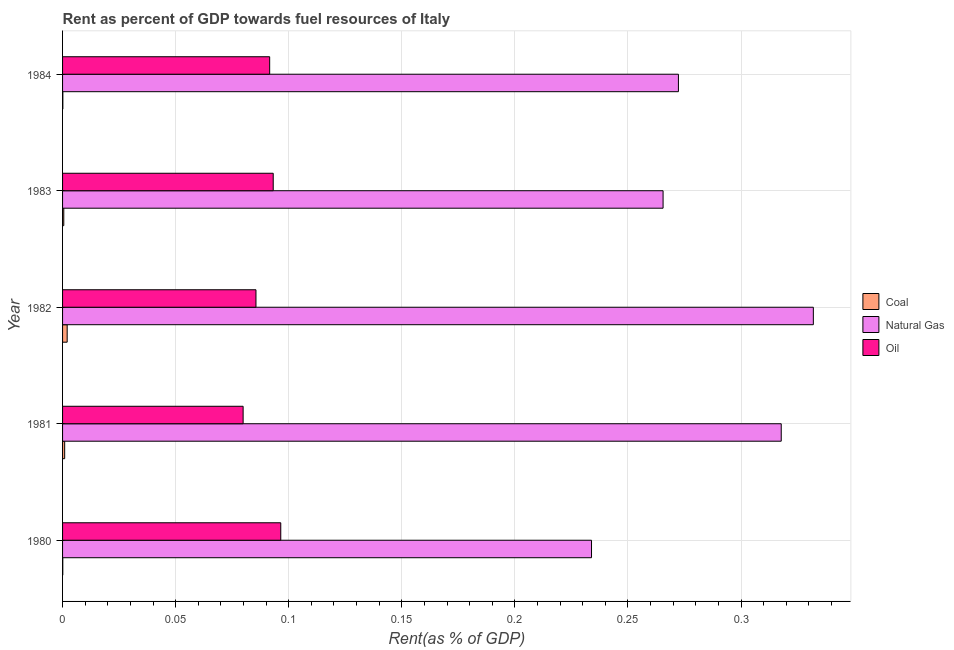How many different coloured bars are there?
Your answer should be compact. 3. Are the number of bars per tick equal to the number of legend labels?
Your answer should be very brief. Yes. Are the number of bars on each tick of the Y-axis equal?
Your response must be concise. Yes. How many bars are there on the 2nd tick from the bottom?
Offer a very short reply. 3. What is the label of the 2nd group of bars from the top?
Offer a very short reply. 1983. What is the rent towards coal in 1984?
Keep it short and to the point. 0. Across all years, what is the maximum rent towards oil?
Your answer should be very brief. 0.1. Across all years, what is the minimum rent towards oil?
Offer a very short reply. 0.08. What is the total rent towards oil in the graph?
Your answer should be compact. 0.45. What is the difference between the rent towards coal in 1980 and that in 1984?
Make the answer very short. -0. What is the difference between the rent towards coal in 1983 and the rent towards oil in 1981?
Offer a terse response. -0.08. What is the average rent towards coal per year?
Make the answer very short. 0. In the year 1984, what is the difference between the rent towards oil and rent towards natural gas?
Keep it short and to the point. -0.18. In how many years, is the rent towards coal greater than 0.03 %?
Your answer should be very brief. 0. What is the ratio of the rent towards oil in 1980 to that in 1981?
Keep it short and to the point. 1.21. Is the difference between the rent towards coal in 1981 and 1982 greater than the difference between the rent towards natural gas in 1981 and 1982?
Give a very brief answer. Yes. What is the difference between the highest and the second highest rent towards natural gas?
Give a very brief answer. 0.01. What does the 3rd bar from the top in 1980 represents?
Give a very brief answer. Coal. What does the 2nd bar from the bottom in 1983 represents?
Your answer should be compact. Natural Gas. Is it the case that in every year, the sum of the rent towards coal and rent towards natural gas is greater than the rent towards oil?
Make the answer very short. Yes. How many bars are there?
Provide a short and direct response. 15. Are all the bars in the graph horizontal?
Ensure brevity in your answer.  Yes. Are the values on the major ticks of X-axis written in scientific E-notation?
Your answer should be very brief. No. Where does the legend appear in the graph?
Your response must be concise. Center right. How many legend labels are there?
Your answer should be very brief. 3. What is the title of the graph?
Your answer should be very brief. Rent as percent of GDP towards fuel resources of Italy. Does "Ages 20-60" appear as one of the legend labels in the graph?
Make the answer very short. No. What is the label or title of the X-axis?
Offer a terse response. Rent(as % of GDP). What is the label or title of the Y-axis?
Provide a succinct answer. Year. What is the Rent(as % of GDP) in Coal in 1980?
Your answer should be compact. 9.6418290567852e-5. What is the Rent(as % of GDP) in Natural Gas in 1980?
Your response must be concise. 0.23. What is the Rent(as % of GDP) of Oil in 1980?
Your answer should be very brief. 0.1. What is the Rent(as % of GDP) of Coal in 1981?
Provide a short and direct response. 0. What is the Rent(as % of GDP) in Natural Gas in 1981?
Give a very brief answer. 0.32. What is the Rent(as % of GDP) of Oil in 1981?
Provide a short and direct response. 0.08. What is the Rent(as % of GDP) in Coal in 1982?
Your response must be concise. 0. What is the Rent(as % of GDP) in Natural Gas in 1982?
Offer a terse response. 0.33. What is the Rent(as % of GDP) of Oil in 1982?
Offer a terse response. 0.09. What is the Rent(as % of GDP) of Coal in 1983?
Provide a short and direct response. 0. What is the Rent(as % of GDP) of Natural Gas in 1983?
Provide a succinct answer. 0.27. What is the Rent(as % of GDP) of Oil in 1983?
Give a very brief answer. 0.09. What is the Rent(as % of GDP) in Coal in 1984?
Offer a terse response. 0. What is the Rent(as % of GDP) in Natural Gas in 1984?
Give a very brief answer. 0.27. What is the Rent(as % of GDP) of Oil in 1984?
Give a very brief answer. 0.09. Across all years, what is the maximum Rent(as % of GDP) in Coal?
Your answer should be compact. 0. Across all years, what is the maximum Rent(as % of GDP) of Natural Gas?
Ensure brevity in your answer.  0.33. Across all years, what is the maximum Rent(as % of GDP) in Oil?
Keep it short and to the point. 0.1. Across all years, what is the minimum Rent(as % of GDP) in Coal?
Your answer should be compact. 9.6418290567852e-5. Across all years, what is the minimum Rent(as % of GDP) of Natural Gas?
Offer a very short reply. 0.23. Across all years, what is the minimum Rent(as % of GDP) of Oil?
Ensure brevity in your answer.  0.08. What is the total Rent(as % of GDP) of Coal in the graph?
Offer a terse response. 0. What is the total Rent(as % of GDP) in Natural Gas in the graph?
Ensure brevity in your answer.  1.42. What is the total Rent(as % of GDP) in Oil in the graph?
Provide a succinct answer. 0.45. What is the difference between the Rent(as % of GDP) of Coal in 1980 and that in 1981?
Give a very brief answer. -0. What is the difference between the Rent(as % of GDP) of Natural Gas in 1980 and that in 1981?
Offer a terse response. -0.08. What is the difference between the Rent(as % of GDP) of Oil in 1980 and that in 1981?
Make the answer very short. 0.02. What is the difference between the Rent(as % of GDP) in Coal in 1980 and that in 1982?
Ensure brevity in your answer.  -0. What is the difference between the Rent(as % of GDP) in Natural Gas in 1980 and that in 1982?
Offer a very short reply. -0.1. What is the difference between the Rent(as % of GDP) of Oil in 1980 and that in 1982?
Your answer should be very brief. 0.01. What is the difference between the Rent(as % of GDP) of Coal in 1980 and that in 1983?
Your answer should be compact. -0. What is the difference between the Rent(as % of GDP) in Natural Gas in 1980 and that in 1983?
Provide a short and direct response. -0.03. What is the difference between the Rent(as % of GDP) of Oil in 1980 and that in 1983?
Provide a short and direct response. 0. What is the difference between the Rent(as % of GDP) in Coal in 1980 and that in 1984?
Offer a terse response. -0. What is the difference between the Rent(as % of GDP) in Natural Gas in 1980 and that in 1984?
Provide a short and direct response. -0.04. What is the difference between the Rent(as % of GDP) in Oil in 1980 and that in 1984?
Give a very brief answer. 0. What is the difference between the Rent(as % of GDP) in Coal in 1981 and that in 1982?
Make the answer very short. -0. What is the difference between the Rent(as % of GDP) in Natural Gas in 1981 and that in 1982?
Your answer should be very brief. -0.01. What is the difference between the Rent(as % of GDP) in Oil in 1981 and that in 1982?
Ensure brevity in your answer.  -0.01. What is the difference between the Rent(as % of GDP) in Natural Gas in 1981 and that in 1983?
Your response must be concise. 0.05. What is the difference between the Rent(as % of GDP) of Oil in 1981 and that in 1983?
Make the answer very short. -0.01. What is the difference between the Rent(as % of GDP) of Coal in 1981 and that in 1984?
Offer a very short reply. 0. What is the difference between the Rent(as % of GDP) in Natural Gas in 1981 and that in 1984?
Ensure brevity in your answer.  0.05. What is the difference between the Rent(as % of GDP) in Oil in 1981 and that in 1984?
Offer a terse response. -0.01. What is the difference between the Rent(as % of GDP) of Coal in 1982 and that in 1983?
Give a very brief answer. 0. What is the difference between the Rent(as % of GDP) in Natural Gas in 1982 and that in 1983?
Keep it short and to the point. 0.07. What is the difference between the Rent(as % of GDP) in Oil in 1982 and that in 1983?
Offer a very short reply. -0.01. What is the difference between the Rent(as % of GDP) in Coal in 1982 and that in 1984?
Offer a very short reply. 0. What is the difference between the Rent(as % of GDP) in Natural Gas in 1982 and that in 1984?
Make the answer very short. 0.06. What is the difference between the Rent(as % of GDP) in Oil in 1982 and that in 1984?
Your answer should be compact. -0.01. What is the difference between the Rent(as % of GDP) in Natural Gas in 1983 and that in 1984?
Provide a short and direct response. -0.01. What is the difference between the Rent(as % of GDP) in Oil in 1983 and that in 1984?
Keep it short and to the point. 0. What is the difference between the Rent(as % of GDP) in Coal in 1980 and the Rent(as % of GDP) in Natural Gas in 1981?
Provide a short and direct response. -0.32. What is the difference between the Rent(as % of GDP) in Coal in 1980 and the Rent(as % of GDP) in Oil in 1981?
Give a very brief answer. -0.08. What is the difference between the Rent(as % of GDP) of Natural Gas in 1980 and the Rent(as % of GDP) of Oil in 1981?
Your answer should be compact. 0.15. What is the difference between the Rent(as % of GDP) of Coal in 1980 and the Rent(as % of GDP) of Natural Gas in 1982?
Give a very brief answer. -0.33. What is the difference between the Rent(as % of GDP) in Coal in 1980 and the Rent(as % of GDP) in Oil in 1982?
Offer a very short reply. -0.09. What is the difference between the Rent(as % of GDP) in Natural Gas in 1980 and the Rent(as % of GDP) in Oil in 1982?
Ensure brevity in your answer.  0.15. What is the difference between the Rent(as % of GDP) in Coal in 1980 and the Rent(as % of GDP) in Natural Gas in 1983?
Provide a succinct answer. -0.27. What is the difference between the Rent(as % of GDP) of Coal in 1980 and the Rent(as % of GDP) of Oil in 1983?
Your answer should be compact. -0.09. What is the difference between the Rent(as % of GDP) in Natural Gas in 1980 and the Rent(as % of GDP) in Oil in 1983?
Offer a terse response. 0.14. What is the difference between the Rent(as % of GDP) of Coal in 1980 and the Rent(as % of GDP) of Natural Gas in 1984?
Make the answer very short. -0.27. What is the difference between the Rent(as % of GDP) in Coal in 1980 and the Rent(as % of GDP) in Oil in 1984?
Give a very brief answer. -0.09. What is the difference between the Rent(as % of GDP) of Natural Gas in 1980 and the Rent(as % of GDP) of Oil in 1984?
Offer a very short reply. 0.14. What is the difference between the Rent(as % of GDP) of Coal in 1981 and the Rent(as % of GDP) of Natural Gas in 1982?
Make the answer very short. -0.33. What is the difference between the Rent(as % of GDP) of Coal in 1981 and the Rent(as % of GDP) of Oil in 1982?
Your response must be concise. -0.08. What is the difference between the Rent(as % of GDP) in Natural Gas in 1981 and the Rent(as % of GDP) in Oil in 1982?
Ensure brevity in your answer.  0.23. What is the difference between the Rent(as % of GDP) of Coal in 1981 and the Rent(as % of GDP) of Natural Gas in 1983?
Provide a short and direct response. -0.26. What is the difference between the Rent(as % of GDP) in Coal in 1981 and the Rent(as % of GDP) in Oil in 1983?
Your answer should be compact. -0.09. What is the difference between the Rent(as % of GDP) of Natural Gas in 1981 and the Rent(as % of GDP) of Oil in 1983?
Keep it short and to the point. 0.22. What is the difference between the Rent(as % of GDP) of Coal in 1981 and the Rent(as % of GDP) of Natural Gas in 1984?
Give a very brief answer. -0.27. What is the difference between the Rent(as % of GDP) in Coal in 1981 and the Rent(as % of GDP) in Oil in 1984?
Provide a succinct answer. -0.09. What is the difference between the Rent(as % of GDP) in Natural Gas in 1981 and the Rent(as % of GDP) in Oil in 1984?
Your answer should be compact. 0.23. What is the difference between the Rent(as % of GDP) of Coal in 1982 and the Rent(as % of GDP) of Natural Gas in 1983?
Offer a very short reply. -0.26. What is the difference between the Rent(as % of GDP) in Coal in 1982 and the Rent(as % of GDP) in Oil in 1983?
Ensure brevity in your answer.  -0.09. What is the difference between the Rent(as % of GDP) in Natural Gas in 1982 and the Rent(as % of GDP) in Oil in 1983?
Your response must be concise. 0.24. What is the difference between the Rent(as % of GDP) in Coal in 1982 and the Rent(as % of GDP) in Natural Gas in 1984?
Give a very brief answer. -0.27. What is the difference between the Rent(as % of GDP) of Coal in 1982 and the Rent(as % of GDP) of Oil in 1984?
Ensure brevity in your answer.  -0.09. What is the difference between the Rent(as % of GDP) of Natural Gas in 1982 and the Rent(as % of GDP) of Oil in 1984?
Provide a short and direct response. 0.24. What is the difference between the Rent(as % of GDP) of Coal in 1983 and the Rent(as % of GDP) of Natural Gas in 1984?
Offer a terse response. -0.27. What is the difference between the Rent(as % of GDP) in Coal in 1983 and the Rent(as % of GDP) in Oil in 1984?
Provide a succinct answer. -0.09. What is the difference between the Rent(as % of GDP) in Natural Gas in 1983 and the Rent(as % of GDP) in Oil in 1984?
Your answer should be very brief. 0.17. What is the average Rent(as % of GDP) of Coal per year?
Your answer should be compact. 0. What is the average Rent(as % of GDP) of Natural Gas per year?
Make the answer very short. 0.28. What is the average Rent(as % of GDP) of Oil per year?
Provide a short and direct response. 0.09. In the year 1980, what is the difference between the Rent(as % of GDP) in Coal and Rent(as % of GDP) in Natural Gas?
Offer a terse response. -0.23. In the year 1980, what is the difference between the Rent(as % of GDP) of Coal and Rent(as % of GDP) of Oil?
Offer a terse response. -0.1. In the year 1980, what is the difference between the Rent(as % of GDP) in Natural Gas and Rent(as % of GDP) in Oil?
Your response must be concise. 0.14. In the year 1981, what is the difference between the Rent(as % of GDP) in Coal and Rent(as % of GDP) in Natural Gas?
Your answer should be compact. -0.32. In the year 1981, what is the difference between the Rent(as % of GDP) in Coal and Rent(as % of GDP) in Oil?
Provide a short and direct response. -0.08. In the year 1981, what is the difference between the Rent(as % of GDP) in Natural Gas and Rent(as % of GDP) in Oil?
Give a very brief answer. 0.24. In the year 1982, what is the difference between the Rent(as % of GDP) of Coal and Rent(as % of GDP) of Natural Gas?
Your answer should be very brief. -0.33. In the year 1982, what is the difference between the Rent(as % of GDP) in Coal and Rent(as % of GDP) in Oil?
Keep it short and to the point. -0.08. In the year 1982, what is the difference between the Rent(as % of GDP) in Natural Gas and Rent(as % of GDP) in Oil?
Ensure brevity in your answer.  0.25. In the year 1983, what is the difference between the Rent(as % of GDP) of Coal and Rent(as % of GDP) of Natural Gas?
Make the answer very short. -0.27. In the year 1983, what is the difference between the Rent(as % of GDP) in Coal and Rent(as % of GDP) in Oil?
Provide a short and direct response. -0.09. In the year 1983, what is the difference between the Rent(as % of GDP) of Natural Gas and Rent(as % of GDP) of Oil?
Provide a short and direct response. 0.17. In the year 1984, what is the difference between the Rent(as % of GDP) in Coal and Rent(as % of GDP) in Natural Gas?
Provide a short and direct response. -0.27. In the year 1984, what is the difference between the Rent(as % of GDP) in Coal and Rent(as % of GDP) in Oil?
Ensure brevity in your answer.  -0.09. In the year 1984, what is the difference between the Rent(as % of GDP) of Natural Gas and Rent(as % of GDP) of Oil?
Your answer should be very brief. 0.18. What is the ratio of the Rent(as % of GDP) of Coal in 1980 to that in 1981?
Offer a very short reply. 0.1. What is the ratio of the Rent(as % of GDP) of Natural Gas in 1980 to that in 1981?
Provide a succinct answer. 0.74. What is the ratio of the Rent(as % of GDP) of Oil in 1980 to that in 1981?
Give a very brief answer. 1.21. What is the ratio of the Rent(as % of GDP) in Coal in 1980 to that in 1982?
Your response must be concise. 0.05. What is the ratio of the Rent(as % of GDP) of Natural Gas in 1980 to that in 1982?
Make the answer very short. 0.7. What is the ratio of the Rent(as % of GDP) in Oil in 1980 to that in 1982?
Provide a short and direct response. 1.13. What is the ratio of the Rent(as % of GDP) in Coal in 1980 to that in 1983?
Offer a very short reply. 0.18. What is the ratio of the Rent(as % of GDP) in Natural Gas in 1980 to that in 1983?
Your response must be concise. 0.88. What is the ratio of the Rent(as % of GDP) in Oil in 1980 to that in 1983?
Provide a succinct answer. 1.04. What is the ratio of the Rent(as % of GDP) of Coal in 1980 to that in 1984?
Offer a very short reply. 0.79. What is the ratio of the Rent(as % of GDP) of Natural Gas in 1980 to that in 1984?
Your response must be concise. 0.86. What is the ratio of the Rent(as % of GDP) in Oil in 1980 to that in 1984?
Your response must be concise. 1.05. What is the ratio of the Rent(as % of GDP) of Coal in 1981 to that in 1982?
Provide a succinct answer. 0.46. What is the ratio of the Rent(as % of GDP) in Natural Gas in 1981 to that in 1982?
Ensure brevity in your answer.  0.96. What is the ratio of the Rent(as % of GDP) of Oil in 1981 to that in 1982?
Ensure brevity in your answer.  0.93. What is the ratio of the Rent(as % of GDP) of Coal in 1981 to that in 1983?
Your response must be concise. 1.73. What is the ratio of the Rent(as % of GDP) in Natural Gas in 1981 to that in 1983?
Your response must be concise. 1.2. What is the ratio of the Rent(as % of GDP) of Oil in 1981 to that in 1983?
Provide a succinct answer. 0.86. What is the ratio of the Rent(as % of GDP) of Coal in 1981 to that in 1984?
Offer a very short reply. 7.64. What is the ratio of the Rent(as % of GDP) in Natural Gas in 1981 to that in 1984?
Give a very brief answer. 1.17. What is the ratio of the Rent(as % of GDP) of Oil in 1981 to that in 1984?
Offer a very short reply. 0.87. What is the ratio of the Rent(as % of GDP) of Coal in 1982 to that in 1983?
Provide a succinct answer. 3.79. What is the ratio of the Rent(as % of GDP) in Natural Gas in 1982 to that in 1983?
Provide a short and direct response. 1.25. What is the ratio of the Rent(as % of GDP) of Oil in 1982 to that in 1983?
Make the answer very short. 0.92. What is the ratio of the Rent(as % of GDP) in Coal in 1982 to that in 1984?
Offer a terse response. 16.69. What is the ratio of the Rent(as % of GDP) of Natural Gas in 1982 to that in 1984?
Give a very brief answer. 1.22. What is the ratio of the Rent(as % of GDP) in Oil in 1982 to that in 1984?
Offer a terse response. 0.93. What is the ratio of the Rent(as % of GDP) of Coal in 1983 to that in 1984?
Your answer should be very brief. 4.41. What is the ratio of the Rent(as % of GDP) of Natural Gas in 1983 to that in 1984?
Your answer should be compact. 0.98. What is the ratio of the Rent(as % of GDP) in Oil in 1983 to that in 1984?
Keep it short and to the point. 1.02. What is the difference between the highest and the second highest Rent(as % of GDP) in Coal?
Provide a short and direct response. 0. What is the difference between the highest and the second highest Rent(as % of GDP) of Natural Gas?
Provide a succinct answer. 0.01. What is the difference between the highest and the second highest Rent(as % of GDP) of Oil?
Your answer should be very brief. 0. What is the difference between the highest and the lowest Rent(as % of GDP) in Coal?
Provide a short and direct response. 0. What is the difference between the highest and the lowest Rent(as % of GDP) of Natural Gas?
Offer a terse response. 0.1. What is the difference between the highest and the lowest Rent(as % of GDP) in Oil?
Offer a terse response. 0.02. 